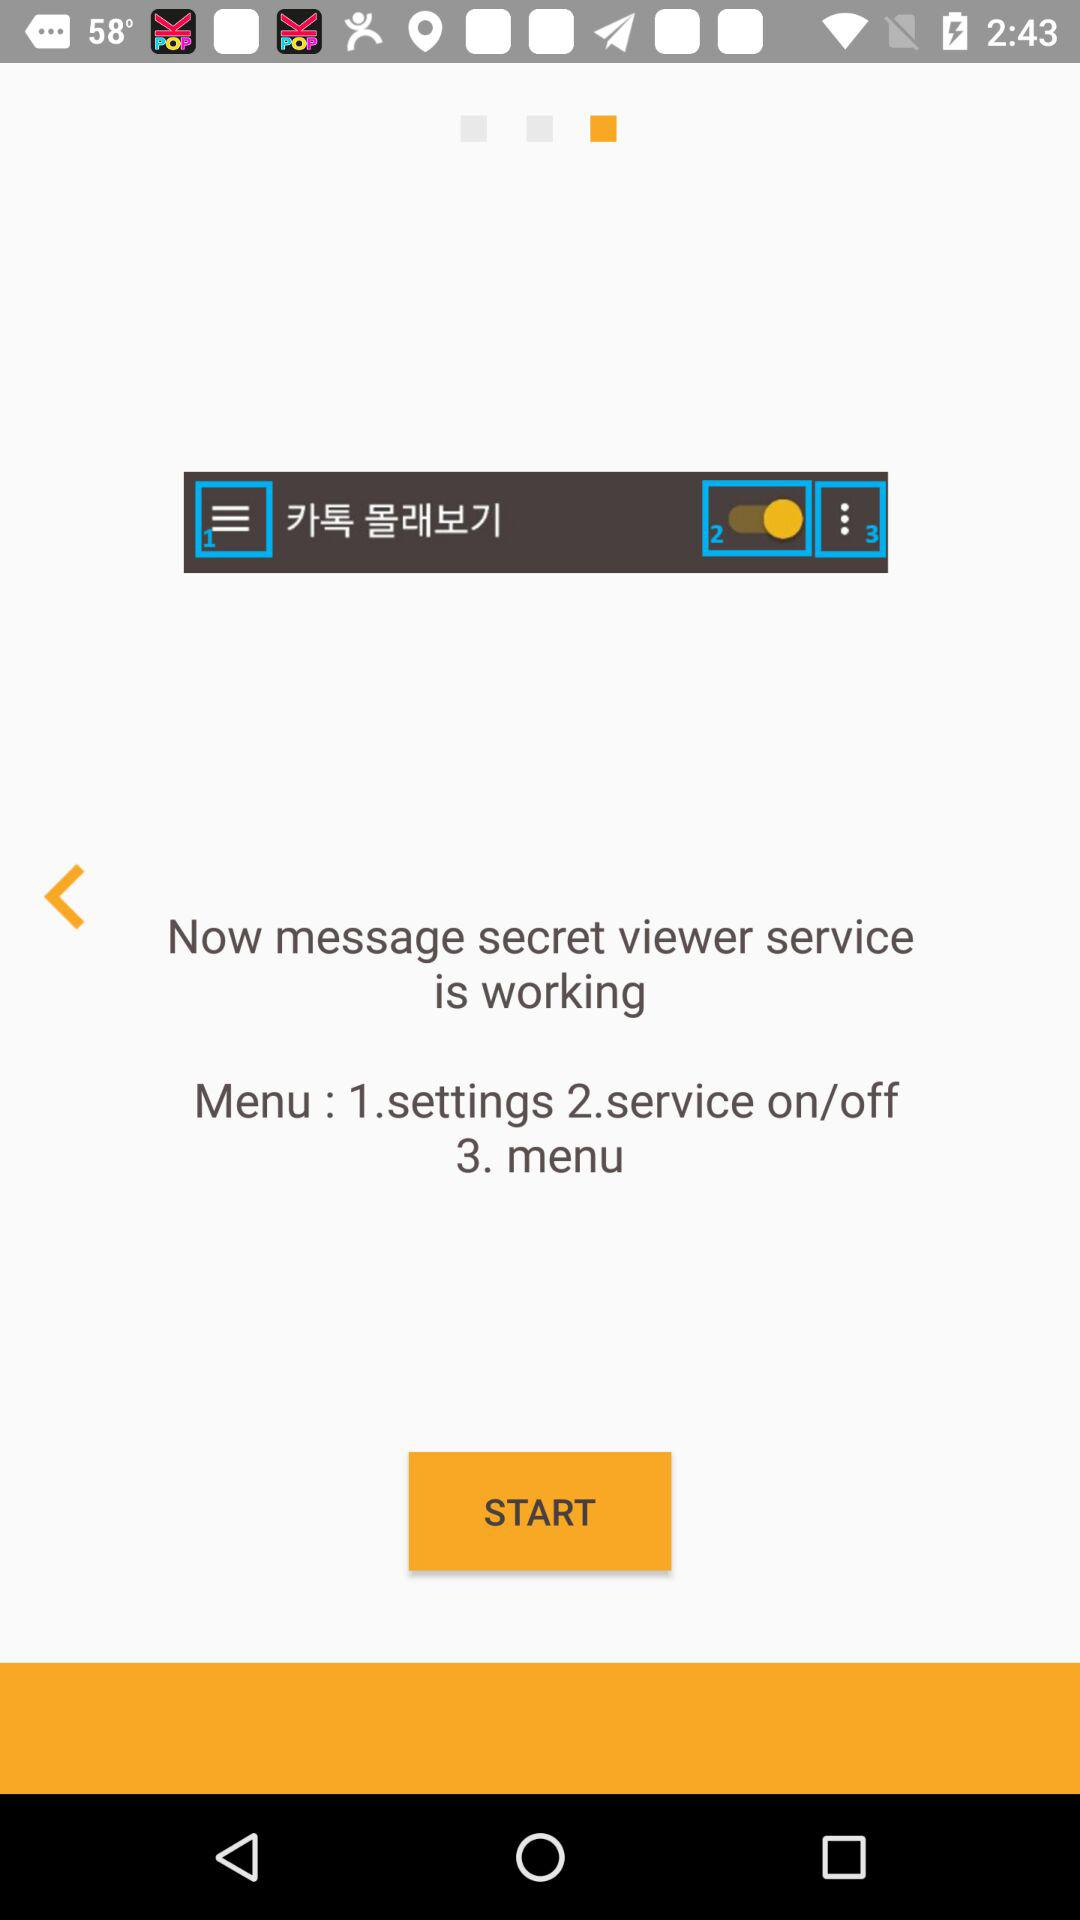How many options are available in the menu?
Answer the question using a single word or phrase. 3 